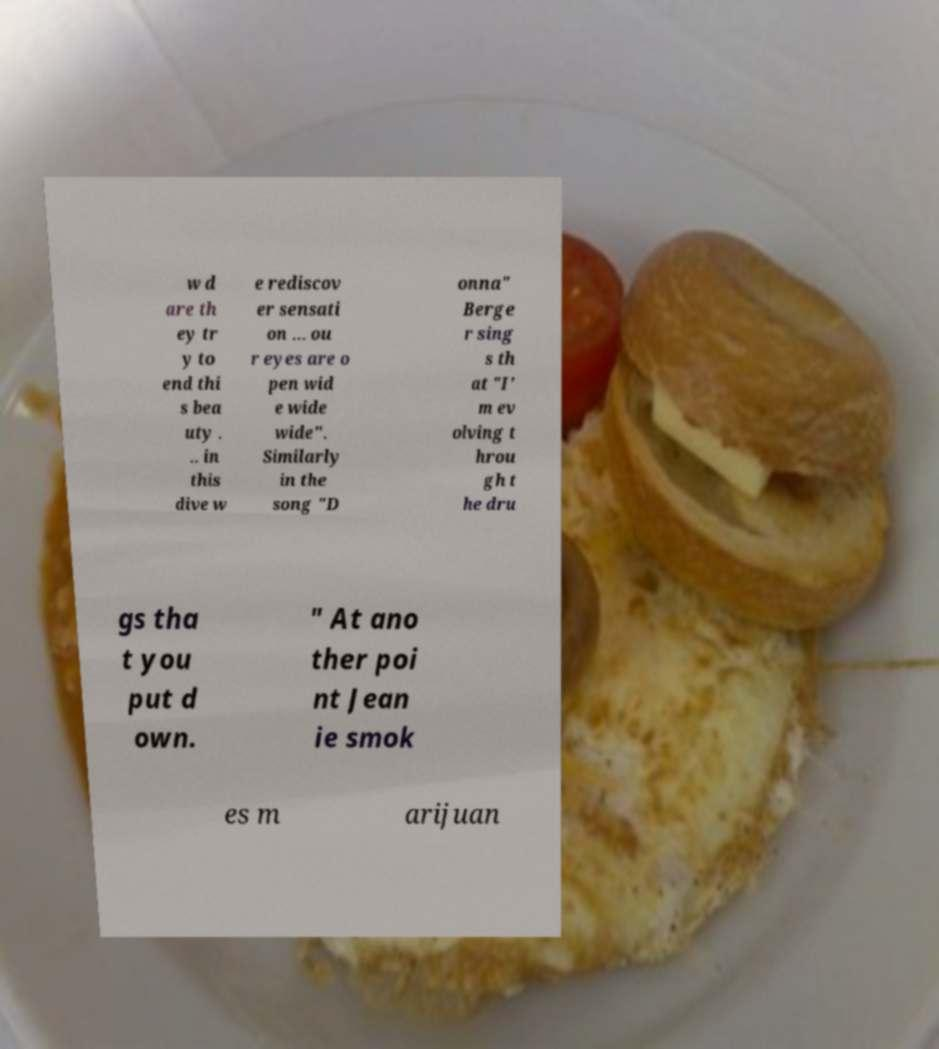I need the written content from this picture converted into text. Can you do that? w d are th ey tr y to end thi s bea uty . .. in this dive w e rediscov er sensati on ... ou r eyes are o pen wid e wide wide". Similarly in the song "D onna" Berge r sing s th at "I' m ev olving t hrou gh t he dru gs tha t you put d own. " At ano ther poi nt Jean ie smok es m arijuan 